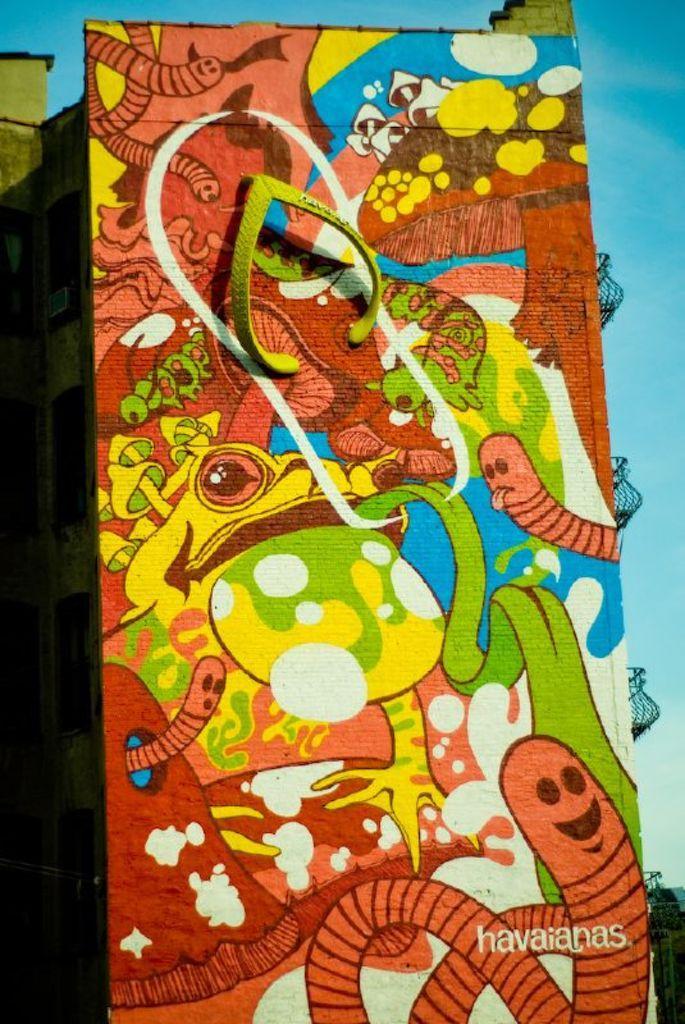Could you give a brief overview of what you see in this image? This image consists of a building wall. On which there are paintings. And we can see a picture of slipper on the wall. On the right, there are balconies. At the top, there is sky. 